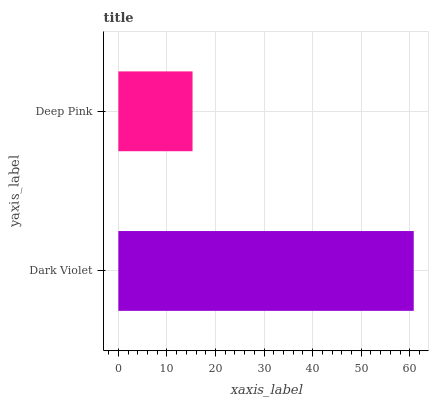Is Deep Pink the minimum?
Answer yes or no. Yes. Is Dark Violet the maximum?
Answer yes or no. Yes. Is Deep Pink the maximum?
Answer yes or no. No. Is Dark Violet greater than Deep Pink?
Answer yes or no. Yes. Is Deep Pink less than Dark Violet?
Answer yes or no. Yes. Is Deep Pink greater than Dark Violet?
Answer yes or no. No. Is Dark Violet less than Deep Pink?
Answer yes or no. No. Is Dark Violet the high median?
Answer yes or no. Yes. Is Deep Pink the low median?
Answer yes or no. Yes. Is Deep Pink the high median?
Answer yes or no. No. Is Dark Violet the low median?
Answer yes or no. No. 